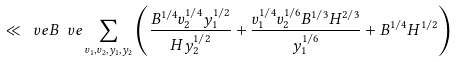Convert formula to latex. <formula><loc_0><loc_0><loc_500><loc_500>\ll _ { \ } v e B ^ { \ } v e \sum _ { v _ { 1 } , v _ { 2 } , y _ { 1 } , y _ { 2 } } \left ( \frac { B ^ { 1 / 4 } v _ { 2 } ^ { 1 / 4 } y _ { 1 } ^ { 1 / 2 } } { H y _ { 2 } ^ { 1 / 2 } } + \frac { v _ { 1 } ^ { 1 / 4 } v _ { 2 } ^ { 1 / 6 } B ^ { 1 / 3 } H ^ { 2 / 3 } } { y _ { 1 } ^ { 1 / 6 } } + { B ^ { 1 / 4 } H ^ { 1 / 2 } } \right )</formula> 